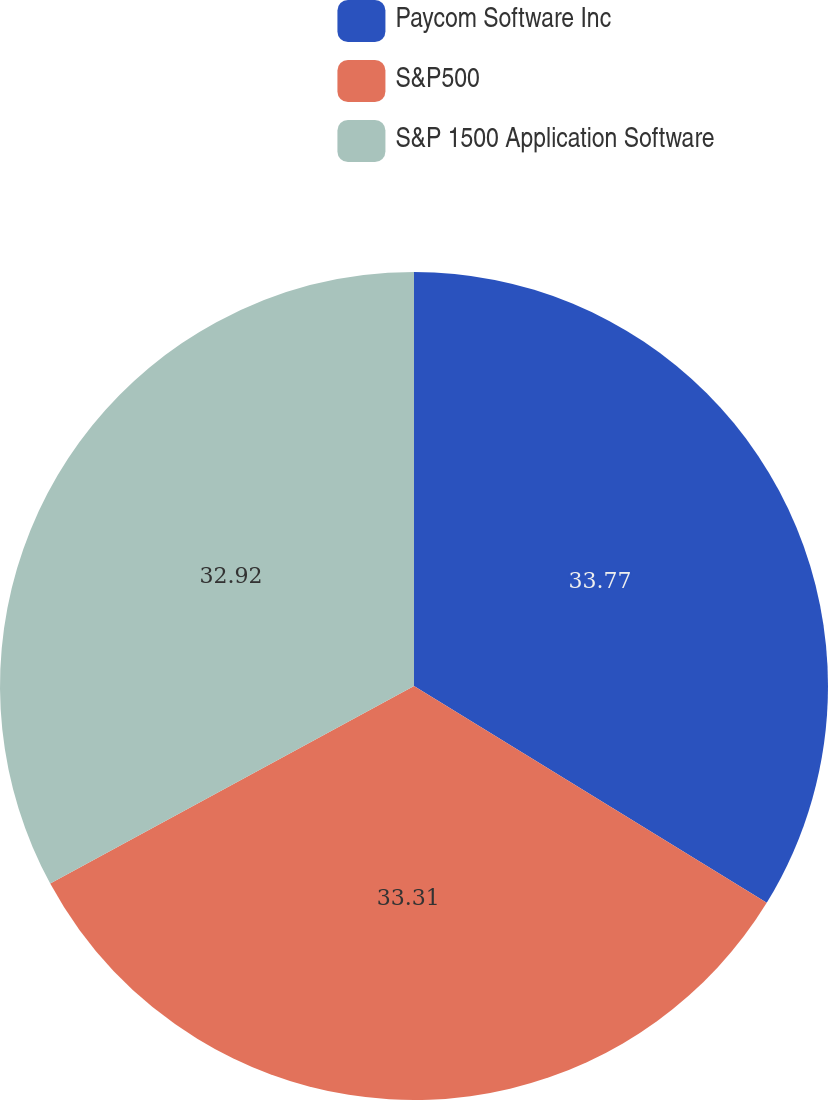<chart> <loc_0><loc_0><loc_500><loc_500><pie_chart><fcel>Paycom Software Inc<fcel>S&P500<fcel>S&P 1500 Application Software<nl><fcel>33.77%<fcel>33.31%<fcel>32.92%<nl></chart> 